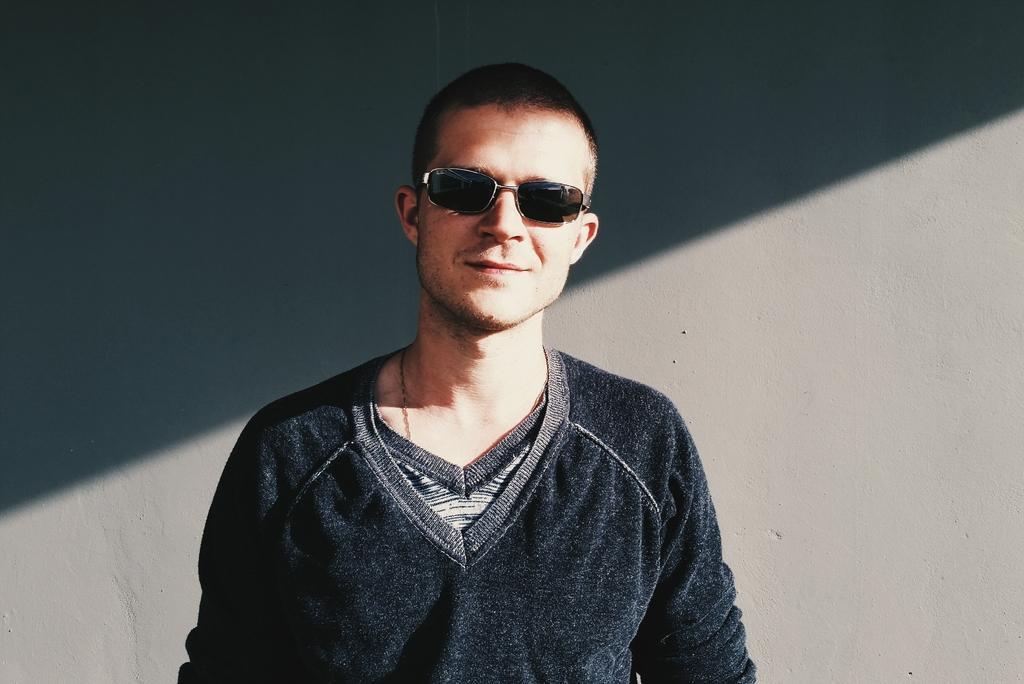Please provide a concise description of this image. In this image I can see the person and the person is wearing black color dress and I can see the gray color background. 